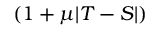<formula> <loc_0><loc_0><loc_500><loc_500>( 1 + \mu | T - S | )</formula> 